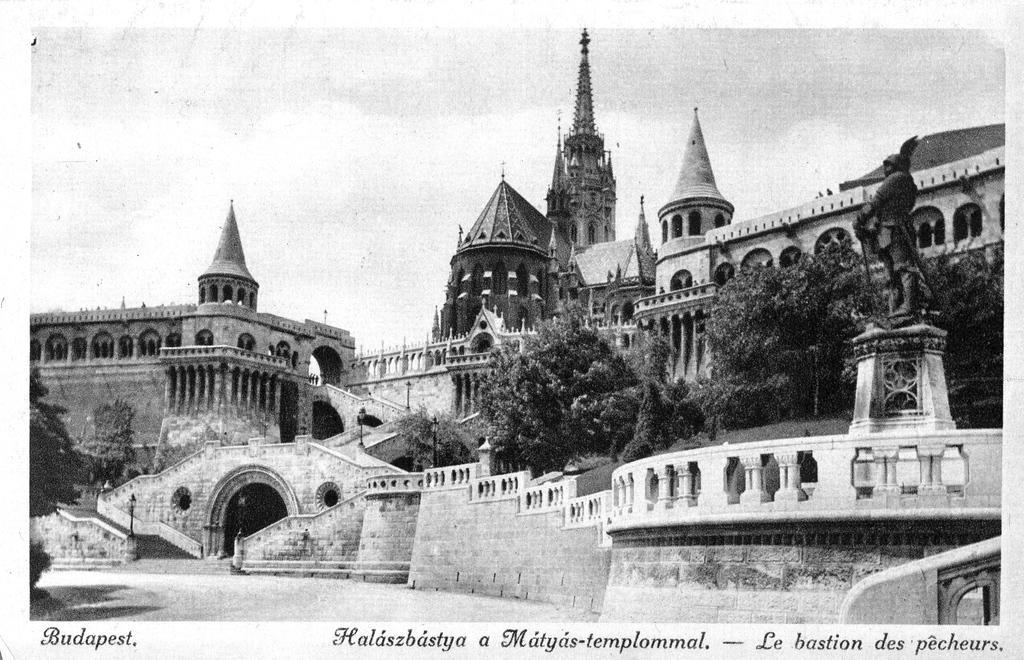Can you describe this image briefly? In this image we can see castles, arch, trees, sculpture and we can also see some text written at the bottom. 